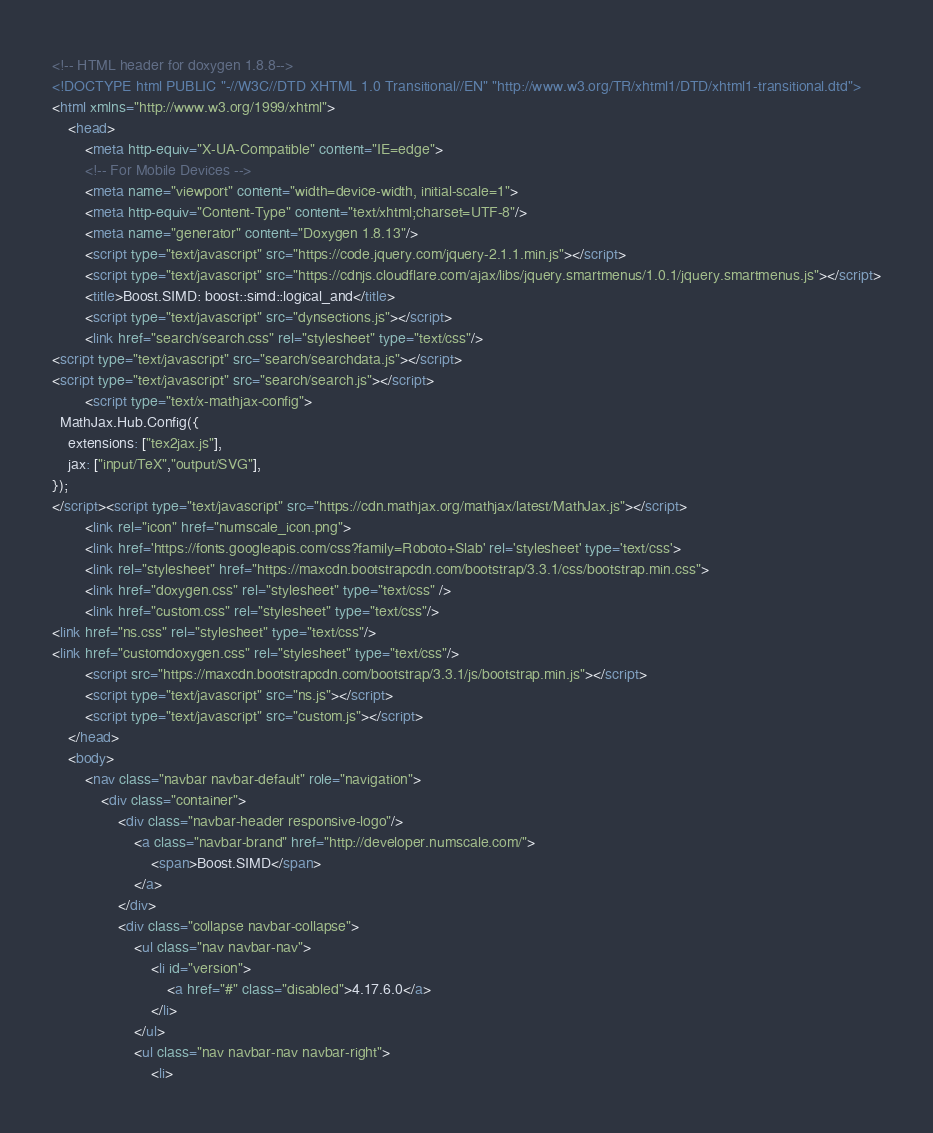Convert code to text. <code><loc_0><loc_0><loc_500><loc_500><_HTML_><!-- HTML header for doxygen 1.8.8-->
<!DOCTYPE html PUBLIC "-//W3C//DTD XHTML 1.0 Transitional//EN" "http://www.w3.org/TR/xhtml1/DTD/xhtml1-transitional.dtd">
<html xmlns="http://www.w3.org/1999/xhtml">
    <head>
        <meta http-equiv="X-UA-Compatible" content="IE=edge">
        <!-- For Mobile Devices -->
        <meta name="viewport" content="width=device-width, initial-scale=1">
        <meta http-equiv="Content-Type" content="text/xhtml;charset=UTF-8"/>
        <meta name="generator" content="Doxygen 1.8.13"/>
        <script type="text/javascript" src="https://code.jquery.com/jquery-2.1.1.min.js"></script>
        <script type="text/javascript" src="https://cdnjs.cloudflare.com/ajax/libs/jquery.smartmenus/1.0.1/jquery.smartmenus.js"></script>
        <title>Boost.SIMD: boost::simd::logical_and</title>
        <script type="text/javascript" src="dynsections.js"></script>
        <link href="search/search.css" rel="stylesheet" type="text/css"/>
<script type="text/javascript" src="search/searchdata.js"></script>
<script type="text/javascript" src="search/search.js"></script>
        <script type="text/x-mathjax-config">
  MathJax.Hub.Config({
    extensions: ["tex2jax.js"],
    jax: ["input/TeX","output/SVG"],
});
</script><script type="text/javascript" src="https://cdn.mathjax.org/mathjax/latest/MathJax.js"></script>
        <link rel="icon" href="numscale_icon.png">
        <link href='https://fonts.googleapis.com/css?family=Roboto+Slab' rel='stylesheet' type='text/css'>
        <link rel="stylesheet" href="https://maxcdn.bootstrapcdn.com/bootstrap/3.3.1/css/bootstrap.min.css">
        <link href="doxygen.css" rel="stylesheet" type="text/css" />
        <link href="custom.css" rel="stylesheet" type="text/css"/>
<link href="ns.css" rel="stylesheet" type="text/css"/>
<link href="customdoxygen.css" rel="stylesheet" type="text/css"/>
        <script src="https://maxcdn.bootstrapcdn.com/bootstrap/3.3.1/js/bootstrap.min.js"></script>
        <script type="text/javascript" src="ns.js"></script>
        <script type="text/javascript" src="custom.js"></script>
    </head>
    <body>
        <nav class="navbar navbar-default" role="navigation">
            <div class="container">
                <div class="navbar-header responsive-logo"/>
                    <a class="navbar-brand" href="http://developer.numscale.com/">
                        <span>Boost.SIMD</span>
                    </a>
                </div>
                <div class="collapse navbar-collapse">
                    <ul class="nav navbar-nav">
                        <li id="version">
                            <a href="#" class="disabled">4.17.6.0</a>
                        </li>
                    </ul>
                    <ul class="nav navbar-nav navbar-right">
                        <li></code> 